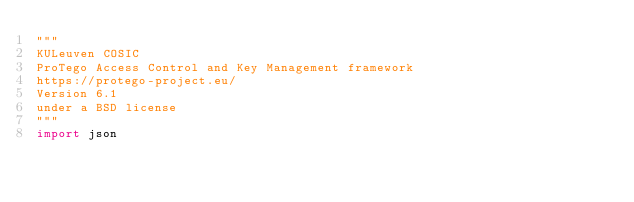<code> <loc_0><loc_0><loc_500><loc_500><_Python_>"""
KULeuven COSIC 
ProTego Access Control and Key Management framework
https://protego-project.eu/
Version 6.1
under a BSD license
"""
import json
</code> 